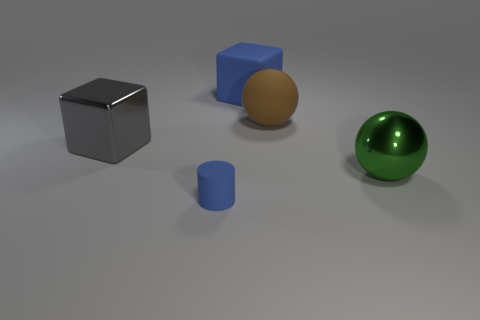Add 4 cylinders. How many objects exist? 9 Subtract all cylinders. How many objects are left? 4 Add 3 big green rubber cubes. How many big green rubber cubes exist? 3 Subtract 0 purple cubes. How many objects are left? 5 Subtract all gray metal things. Subtract all purple balls. How many objects are left? 4 Add 4 large brown matte things. How many large brown matte things are left? 5 